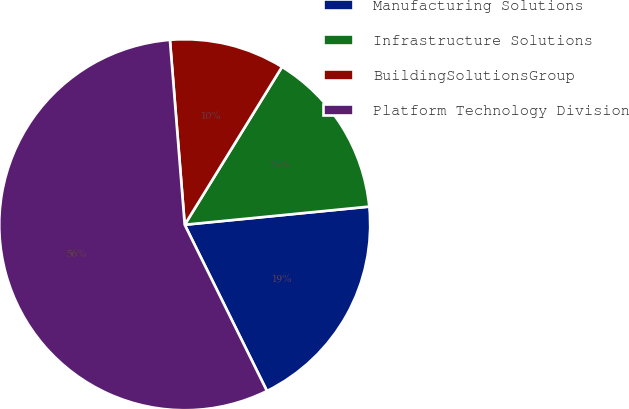Convert chart to OTSL. <chart><loc_0><loc_0><loc_500><loc_500><pie_chart><fcel>Manufacturing Solutions<fcel>Infrastructure Solutions<fcel>BuildingSolutionsGroup<fcel>Platform Technology Division<nl><fcel>19.25%<fcel>14.65%<fcel>10.06%<fcel>56.04%<nl></chart> 